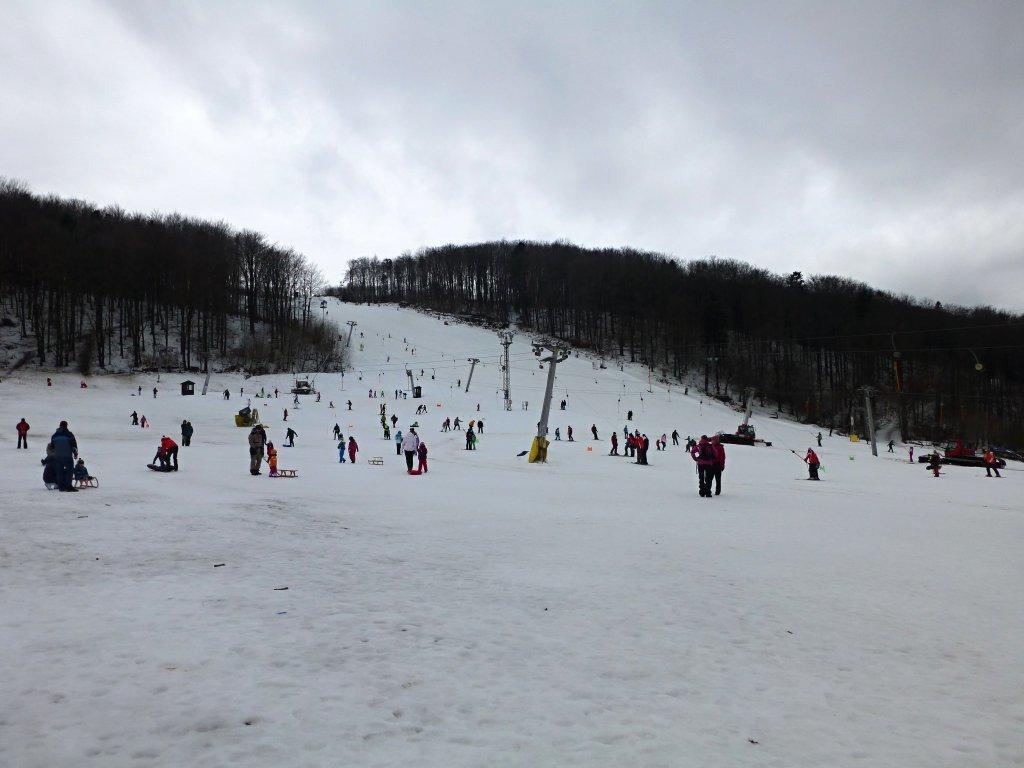Please provide a concise description of this image. In this image, I can few people standing and few people sitting in the snow vehicles. These are the current polls. I can see the trees. This looks like a snowy mountain. 